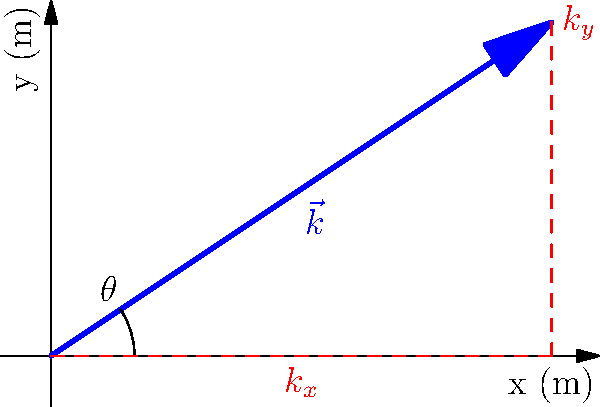As a violinist, you're interested in the physics of sound propagation. Consider a sound wave from your violin traveling with a wave vector $\vec{k}$ as shown in the diagram. If the magnitude of the wave vector is $10 \text{ m}^{-1}$ and it makes an angle $\theta = \tan^{-1}(2/3)$ with the x-axis, what are the x and y components of the wave vector? Let's approach this step-by-step:

1) We're given that the magnitude of the wave vector $|\vec{k}| = 10 \text{ m}^{-1}$ and the angle $\theta = \tan^{-1}(2/3)$.

2) The components of the wave vector are related to its magnitude and angle by:
   $k_x = |\vec{k}| \cos(\theta)$
   $k_y = |\vec{k}| \sin(\theta)$

3) We need to find $\cos(\theta)$ and $\sin(\theta)$:
   In a right triangle with angle $\theta = \tan^{-1}(2/3)$:
   $\cos(\theta) = \frac{3}{\sqrt{3^2 + 2^2}} = \frac{3}{\sqrt{13}}$
   $\sin(\theta) = \frac{2}{\sqrt{3^2 + 2^2}} = \frac{2}{\sqrt{13}}$

4) Now we can calculate the components:
   $k_x = 10 \cdot \frac{3}{\sqrt{13}} = \frac{30}{\sqrt{13}} \approx 8.32 \text{ m}^{-1}$
   $k_y = 10 \cdot \frac{2}{\sqrt{13}} = \frac{20}{\sqrt{13}} \approx 5.55 \text{ m}^{-1}$

5) Therefore, the x and y components of the wave vector are $\frac{30}{\sqrt{13}}$ and $\frac{20}{\sqrt{13}}$ respectively.
Answer: $k_x = \frac{30}{\sqrt{13}} \text{ m}^{-1}$, $k_y = \frac{20}{\sqrt{13}} \text{ m}^{-1}$ 